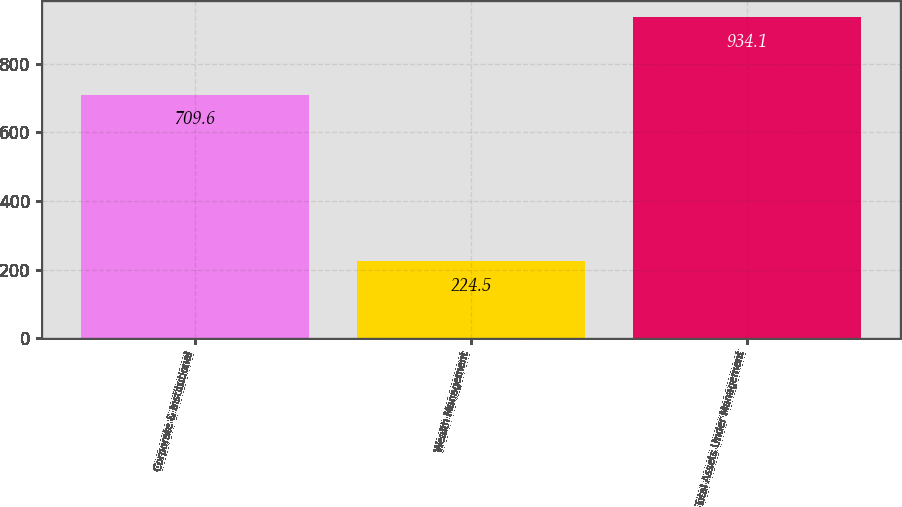Convert chart. <chart><loc_0><loc_0><loc_500><loc_500><bar_chart><fcel>Corporate & Institutional<fcel>Wealth Management<fcel>Total Assets Under Management<nl><fcel>709.6<fcel>224.5<fcel>934.1<nl></chart> 